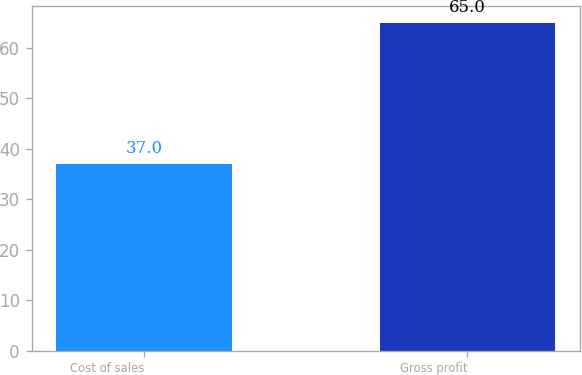Convert chart to OTSL. <chart><loc_0><loc_0><loc_500><loc_500><bar_chart><fcel>Cost of sales<fcel>Gross profit<nl><fcel>37<fcel>65<nl></chart> 